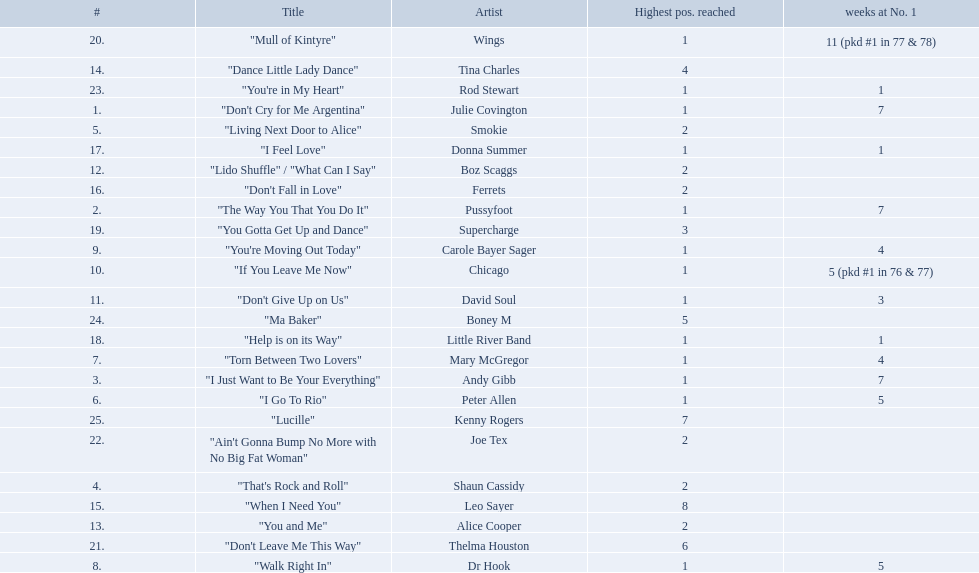How long is the longest amount of time spent at number 1? 11 (pkd #1 in 77 & 78). What song spent 11 weeks at number 1? "Mull of Kintyre". What band had a number 1 hit with this song? Wings. 